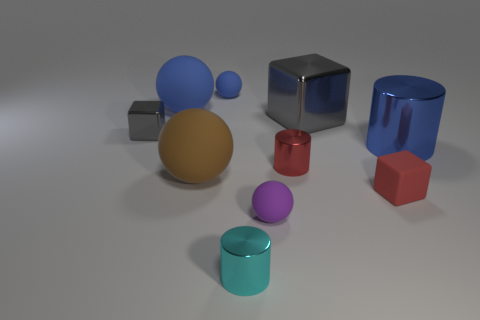Is there any other thing that is made of the same material as the cyan cylinder?
Give a very brief answer. Yes. What number of cylinders are either large green rubber objects or tiny metal objects?
Offer a terse response. 2. There is a metallic cylinder that is on the right side of the large shiny block; does it have the same size as the red object that is in front of the brown matte thing?
Your response must be concise. No. What material is the large sphere in front of the tiny gray shiny block behind the small red shiny thing made of?
Offer a terse response. Rubber. Are there fewer blue cylinders that are behind the red shiny thing than big blue spheres?
Your response must be concise. No. There is a large blue thing that is the same material as the small purple object; what is its shape?
Provide a succinct answer. Sphere. How many other things are there of the same shape as the tiny gray metal thing?
Offer a terse response. 2. What number of yellow things are either blocks or tiny metal blocks?
Give a very brief answer. 0. Does the small gray object have the same shape as the blue metal thing?
Ensure brevity in your answer.  No. There is a gray shiny cube that is behind the small gray metallic cube; is there a tiny purple matte ball behind it?
Offer a very short reply. No. 